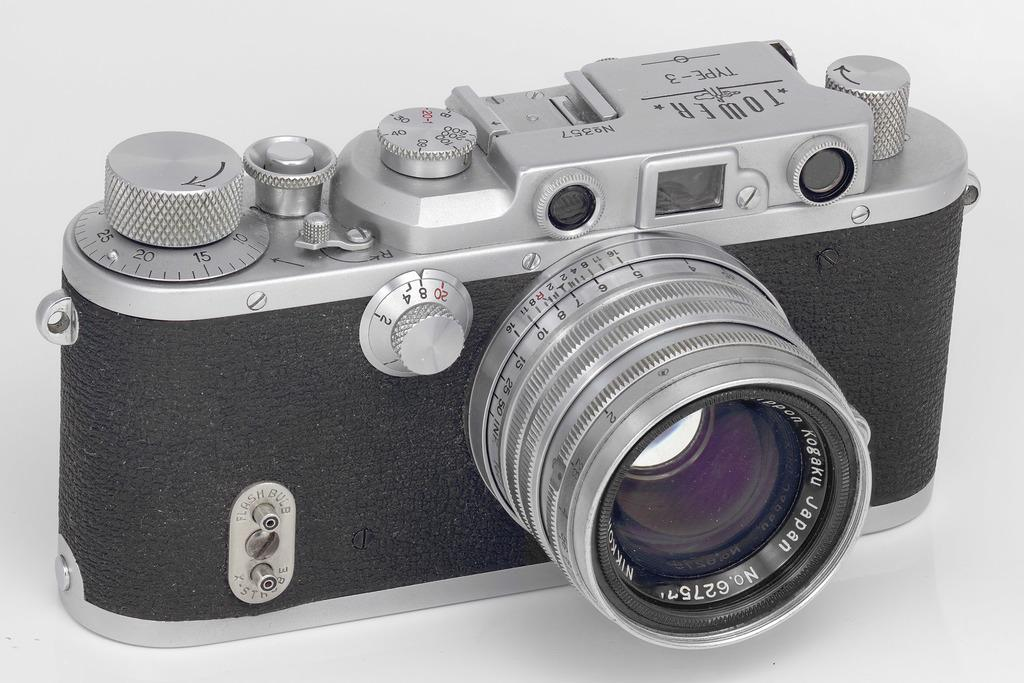What object is the main focus of the image? There is a camera in the image. What color is the background of the image? The background of the image is white. How many fairies are visible in the image? There are no fairies present in the image. What type of crate is used to store the camera in the image? There is no crate present in the image; the camera is not stored in a crate. 